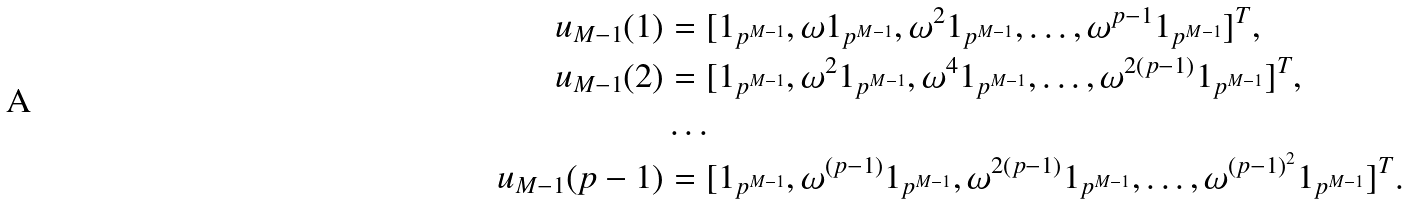Convert formula to latex. <formula><loc_0><loc_0><loc_500><loc_500>u _ { M - 1 } ( 1 ) & = [ 1 _ { p ^ { M - 1 } } , \omega 1 _ { p ^ { M - 1 } } , \omega ^ { 2 } 1 _ { p ^ { M - 1 } } , \dots , \omega ^ { p - 1 } 1 _ { p ^ { M - 1 } } ] ^ { T } , \\ u _ { M - 1 } ( 2 ) & = [ 1 _ { p ^ { M - 1 } } , \omega ^ { 2 } 1 _ { p ^ { M - 1 } } , \omega ^ { 4 } 1 _ { p ^ { M - 1 } } , \dots , \omega ^ { 2 ( p - 1 ) } 1 _ { p ^ { M - 1 } } ] ^ { T } , \\ & \dots \\ u _ { M - 1 } ( p - 1 ) & = [ 1 _ { p ^ { M - 1 } } , \omega ^ { ( p - 1 ) } 1 _ { p ^ { M - 1 } } , \omega ^ { 2 ( p - 1 ) } 1 _ { p ^ { M - 1 } } , \dots , \omega ^ { ( p - 1 ) ^ { 2 } } 1 _ { p ^ { M - 1 } } ] ^ { T } .</formula> 